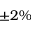<formula> <loc_0><loc_0><loc_500><loc_500>\pm 2 \%</formula> 